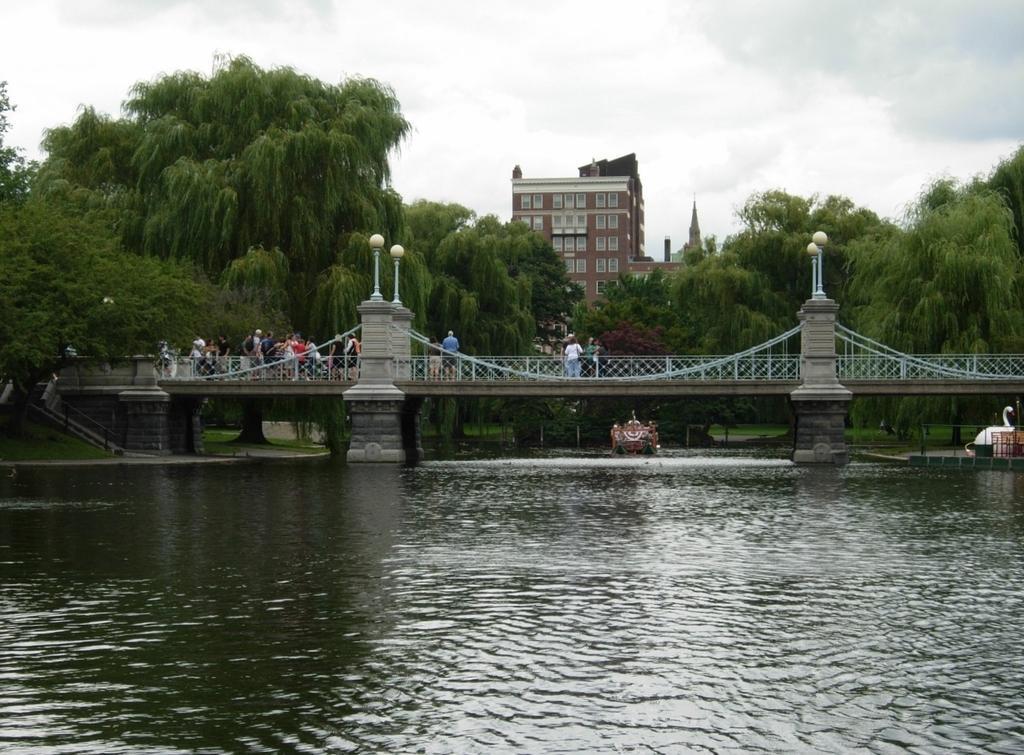Describe this image in one or two sentences. In this image we can see water. On the water there is a boat. Also there is a bridge with pillars, light poles and railings. There are many people on the bridge. In the background there are many trees, building with windows and sky with clouds. 